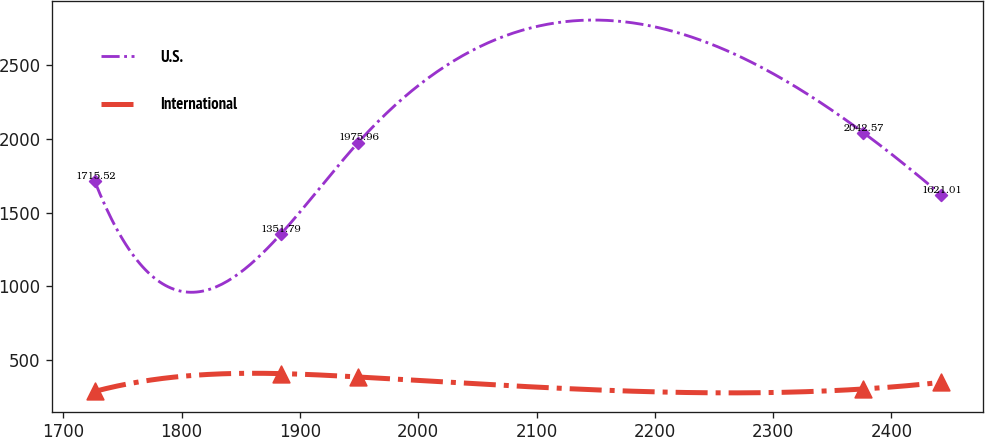Convert chart. <chart><loc_0><loc_0><loc_500><loc_500><line_chart><ecel><fcel>U.S.<fcel>International<nl><fcel>1726.36<fcel>1715.52<fcel>284.73<nl><fcel>1883.56<fcel>1351.79<fcel>405.92<nl><fcel>1949.23<fcel>1975.96<fcel>382.89<nl><fcel>2376.36<fcel>2042.57<fcel>301.41<nl><fcel>2442.03<fcel>1621.01<fcel>346.49<nl></chart> 